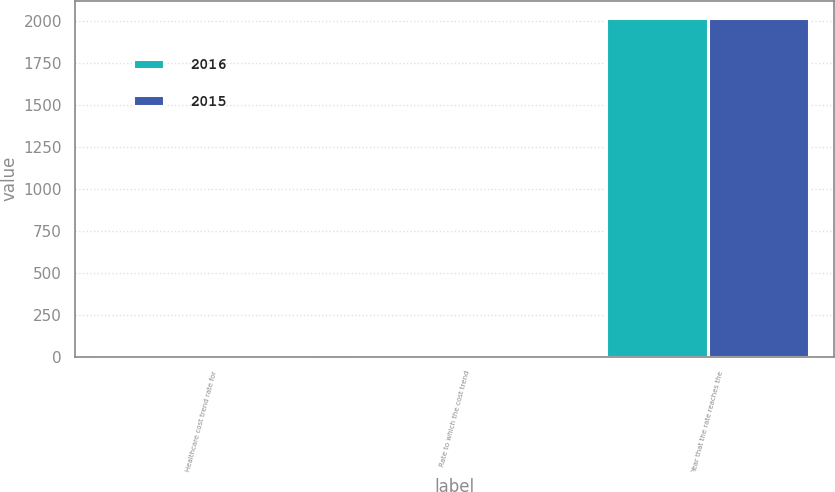Convert chart. <chart><loc_0><loc_0><loc_500><loc_500><stacked_bar_chart><ecel><fcel>Healthcare cost trend rate for<fcel>Rate to which the cost trend<fcel>Year that the rate reaches the<nl><fcel>2016<fcel>7.25<fcel>5<fcel>2021<nl><fcel>2015<fcel>7.5<fcel>5<fcel>2021<nl></chart> 